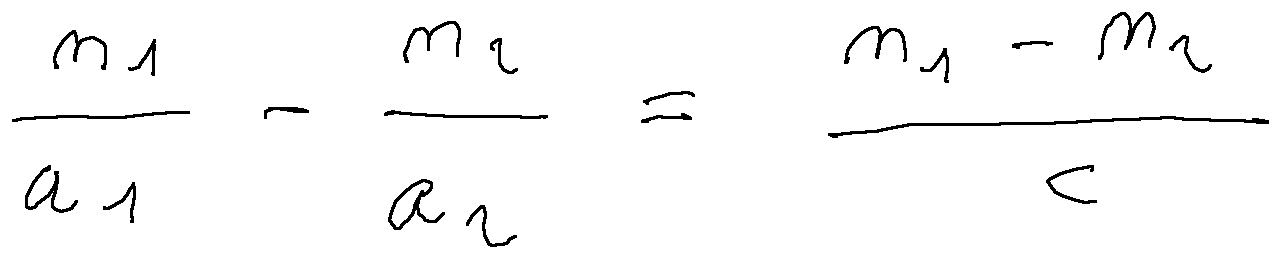<formula> <loc_0><loc_0><loc_500><loc_500>\frac { n _ { 1 } } { a _ { 1 } } - \frac { n _ { 2 } } { a _ { 2 } } = \frac { n _ { 1 } - n _ { 2 } } { c }</formula> 